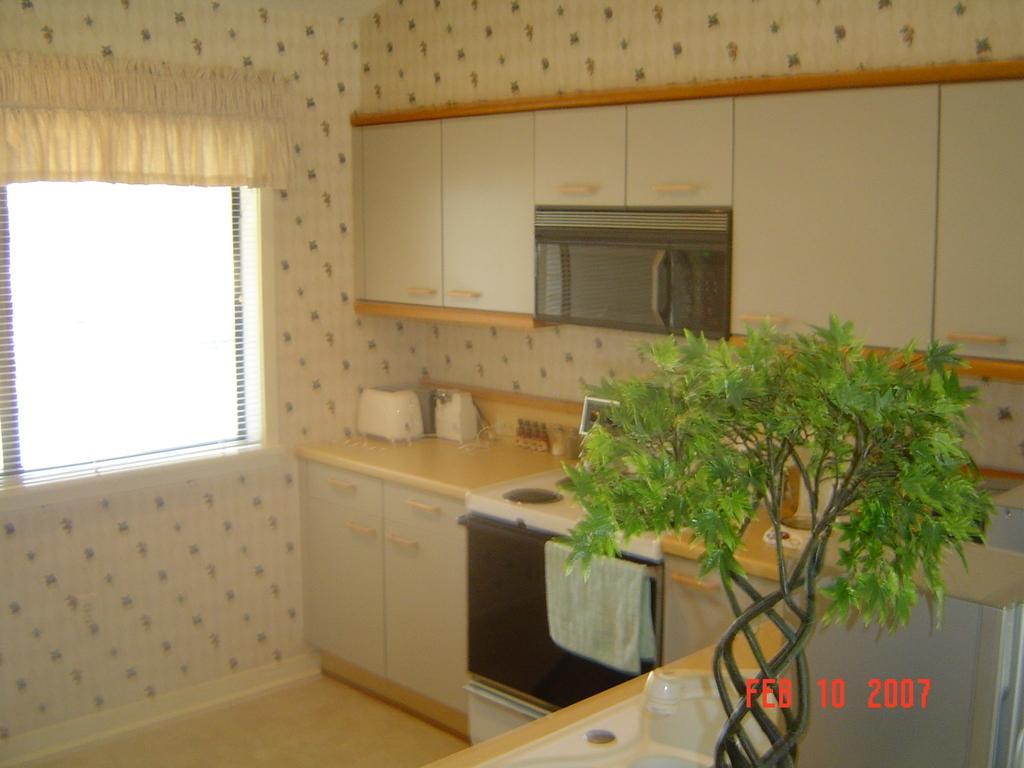How would you summarize this image in a sentence or two? In this image I can see inside view of the kitchen. In the front I can see a plant and a white colour thing. In the background I can see a gas stove, an oven, a cloth, few white colour things on the counter top and number of cupboards. I can also see a microwave in the background and on the left side I can see a window and a curtain. On the bottom right side of the image I can see a watermark. 